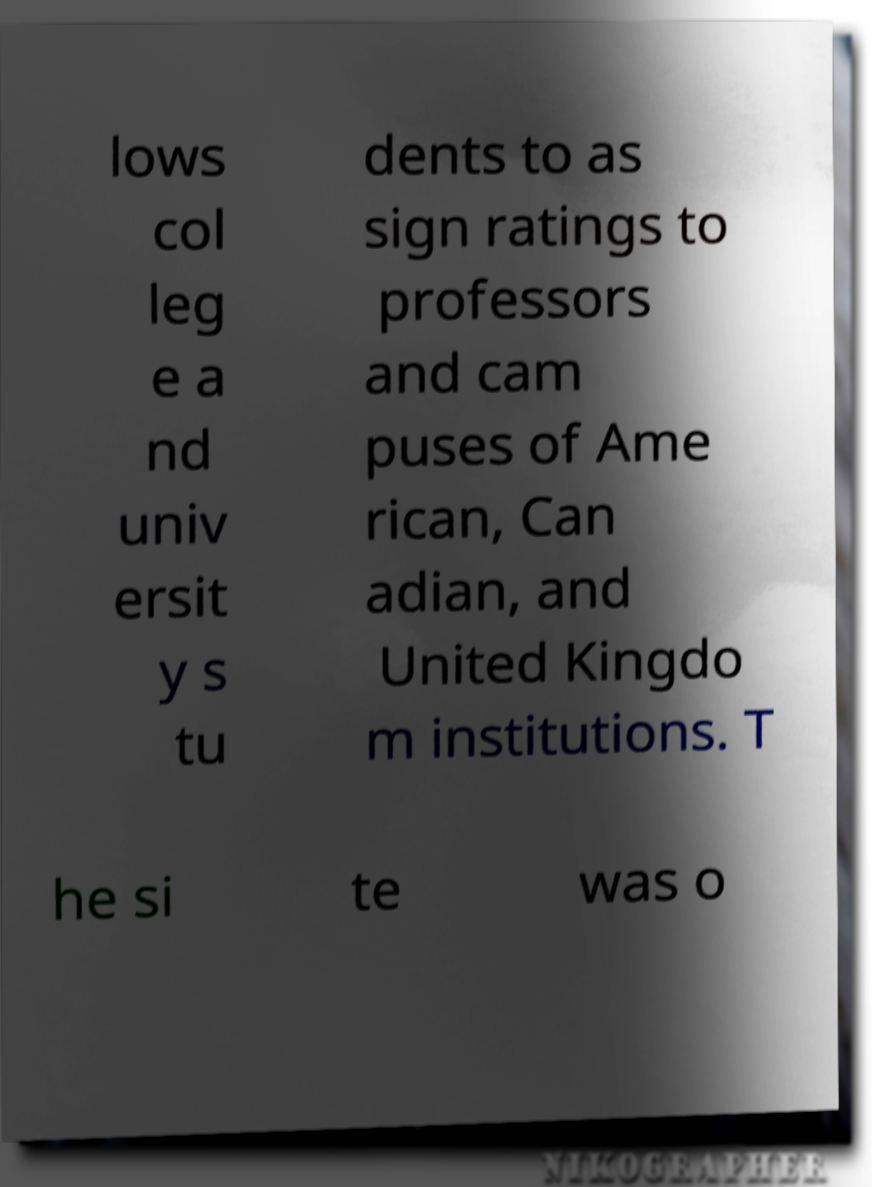There's text embedded in this image that I need extracted. Can you transcribe it verbatim? lows col leg e a nd univ ersit y s tu dents to as sign ratings to professors and cam puses of Ame rican, Can adian, and United Kingdo m institutions. T he si te was o 